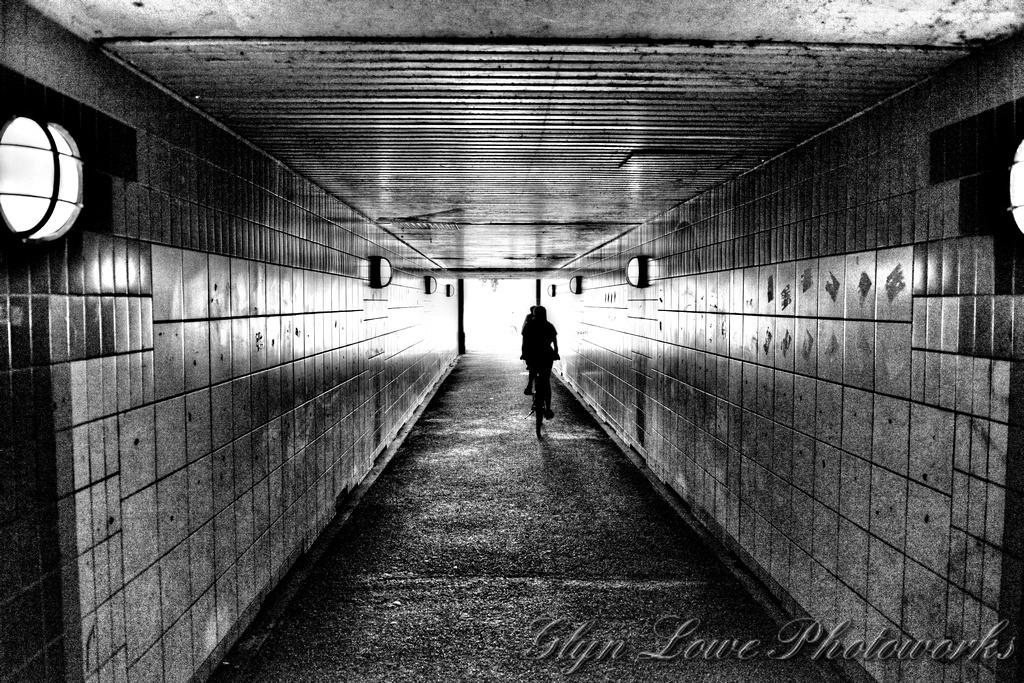What is the color scheme of the image? The image is in black and white. What activity is the person in the image engaged in? There is a person riding a bicycle in the image. What type of structure is visible in the image? There is a wall in the image. What part of a building can be seen in the image? There is a roof in the image. What type of fowl can be seen flying near the person riding the bike in the image? There are no fowl visible in the image; it is in black and white and only features a person riding a bicycle, a wall, and a roof. 